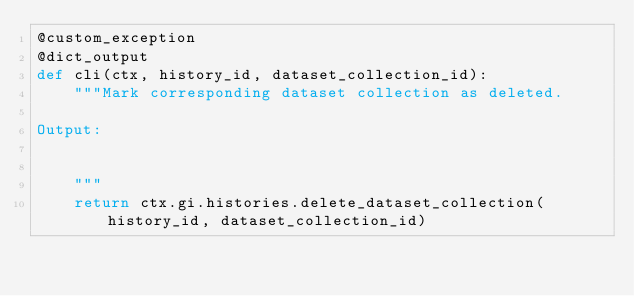<code> <loc_0><loc_0><loc_500><loc_500><_Python_>@custom_exception
@dict_output
def cli(ctx, history_id, dataset_collection_id):
    """Mark corresponding dataset collection as deleted.

Output:

    
    """
    return ctx.gi.histories.delete_dataset_collection(history_id, dataset_collection_id)
</code> 